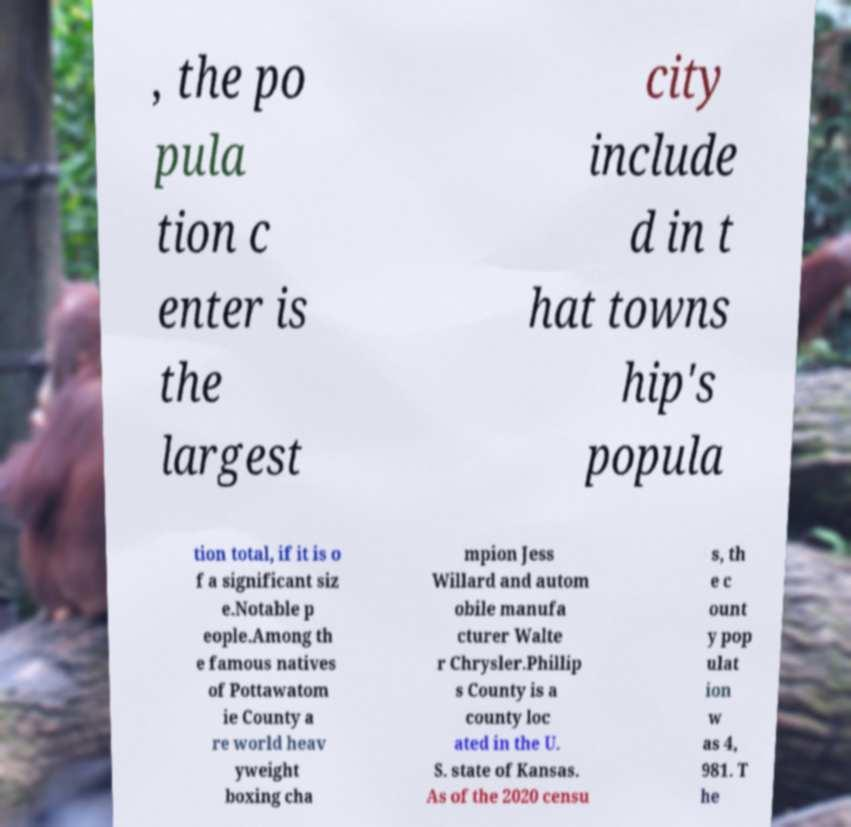For documentation purposes, I need the text within this image transcribed. Could you provide that? , the po pula tion c enter is the largest city include d in t hat towns hip's popula tion total, if it is o f a significant siz e.Notable p eople.Among th e famous natives of Pottawatom ie County a re world heav yweight boxing cha mpion Jess Willard and autom obile manufa cturer Walte r Chrysler.Phillip s County is a county loc ated in the U. S. state of Kansas. As of the 2020 censu s, th e c ount y pop ulat ion w as 4, 981. T he 